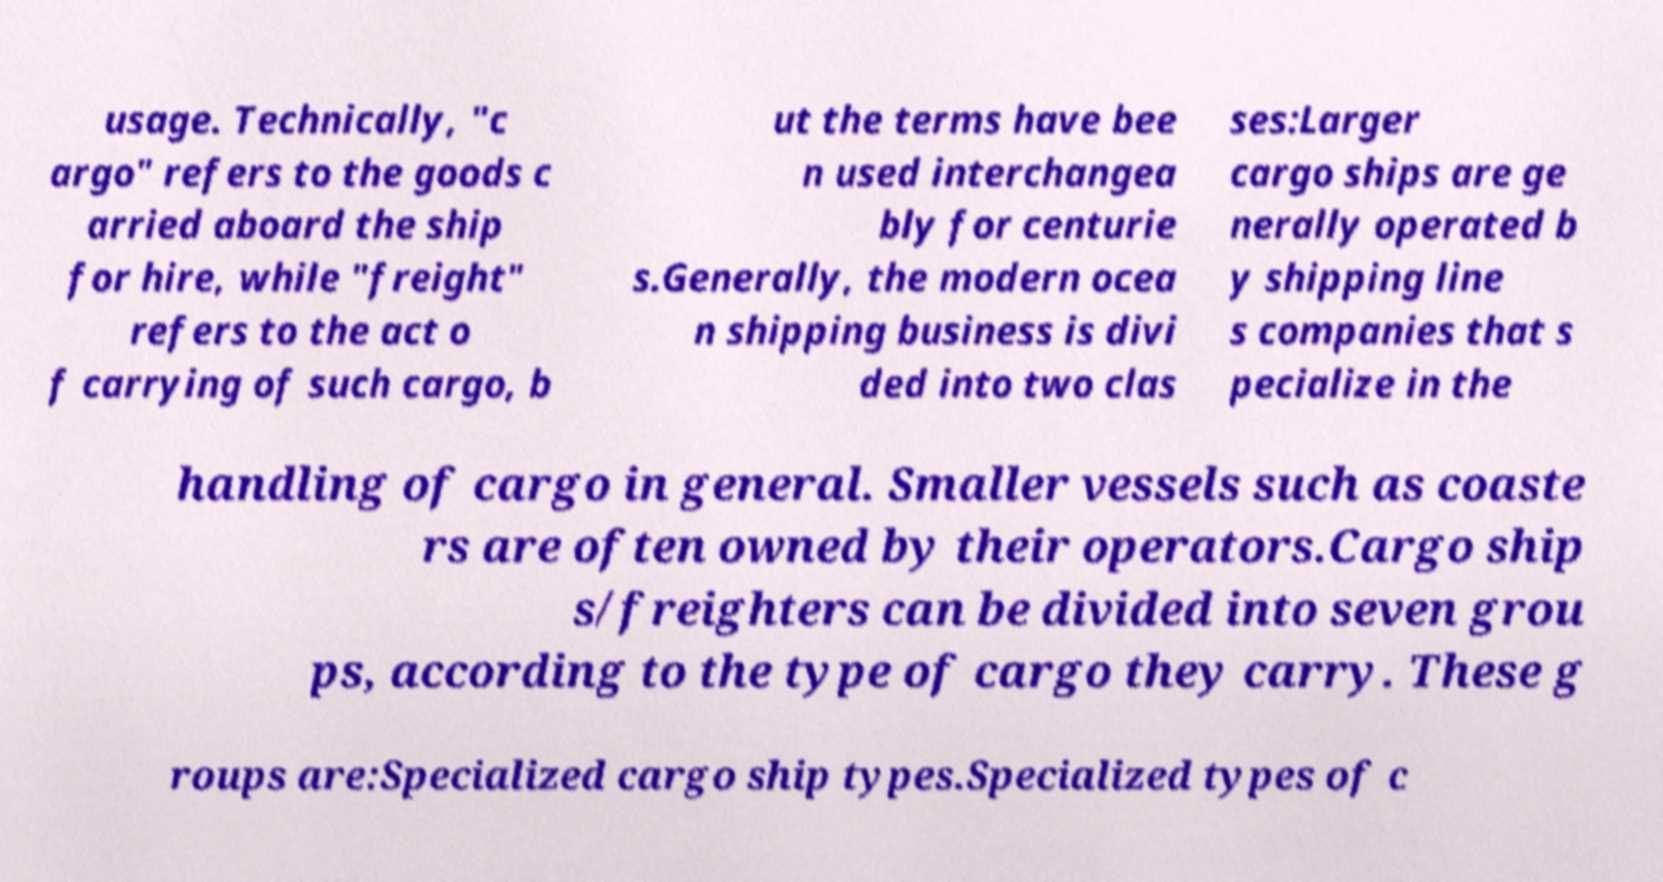Can you read and provide the text displayed in the image?This photo seems to have some interesting text. Can you extract and type it out for me? usage. Technically, "c argo" refers to the goods c arried aboard the ship for hire, while "freight" refers to the act o f carrying of such cargo, b ut the terms have bee n used interchangea bly for centurie s.Generally, the modern ocea n shipping business is divi ded into two clas ses:Larger cargo ships are ge nerally operated b y shipping line s companies that s pecialize in the handling of cargo in general. Smaller vessels such as coaste rs are often owned by their operators.Cargo ship s/freighters can be divided into seven grou ps, according to the type of cargo they carry. These g roups are:Specialized cargo ship types.Specialized types of c 